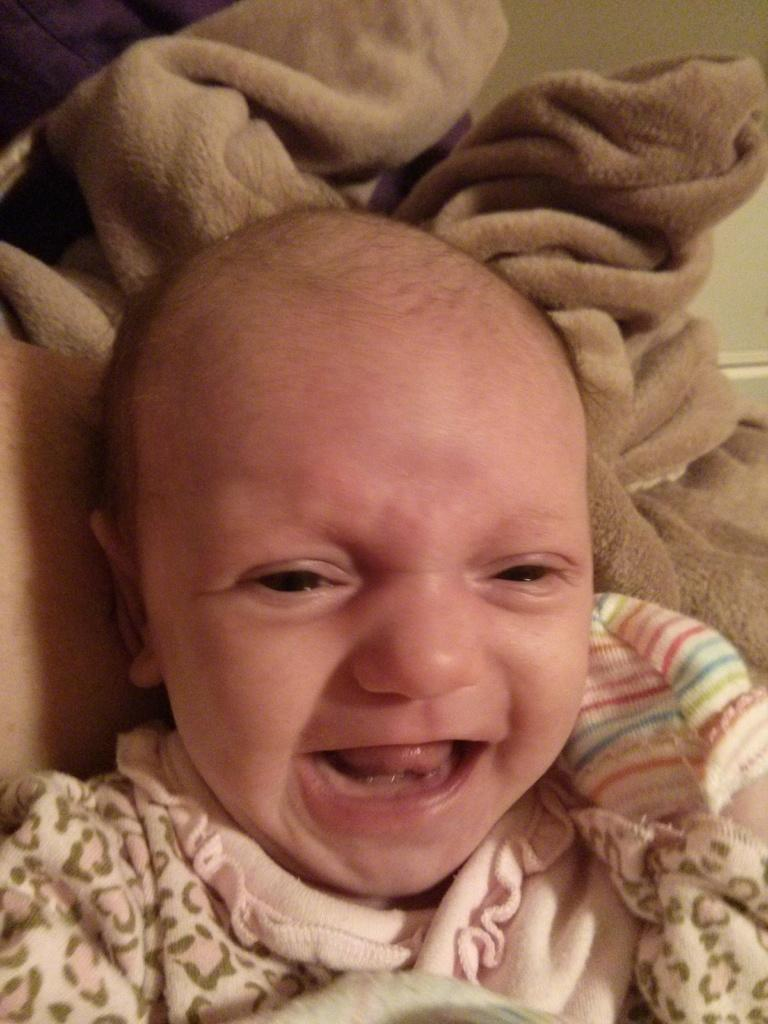What is the main subject of the image? There is a baby in the image. What else can be seen in the image besides the baby? There is cloth in the image. What type of pig can be seen in the scene in the image? There is no pig present in the image; it only features a baby and cloth. Where is the store located in the image? There is no store present in the image. 